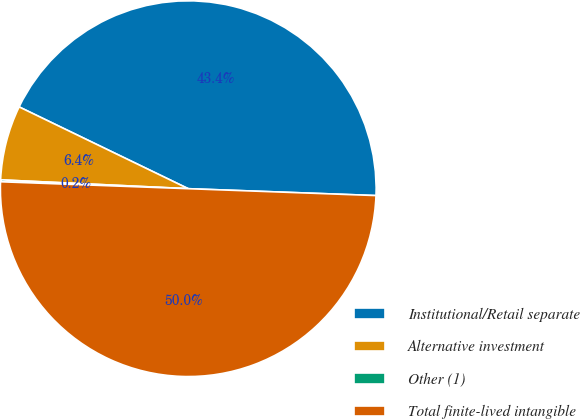Convert chart to OTSL. <chart><loc_0><loc_0><loc_500><loc_500><pie_chart><fcel>Institutional/Retail separate<fcel>Alternative investment<fcel>Other (1)<fcel>Total finite-lived intangible<nl><fcel>43.41%<fcel>6.42%<fcel>0.16%<fcel>50.0%<nl></chart> 